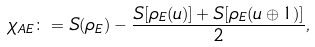<formula> <loc_0><loc_0><loc_500><loc_500>\chi _ { A E } \colon = S ( \rho _ { E } ) - \frac { S [ \rho _ { E } ( u ) ] + S [ \rho _ { E } ( u \oplus 1 ) ] } { 2 } ,</formula> 